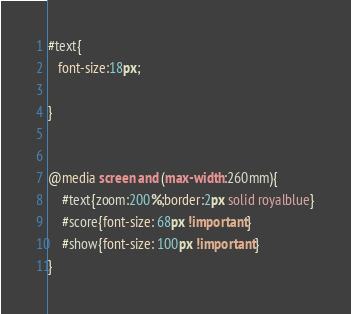<code> <loc_0><loc_0><loc_500><loc_500><_CSS_>#text{
   font-size:18px;

}


@media screen and (max-width:260mm){
    #text{zoom:200%;border:2px solid royalblue}
    #score{font-size: 68px !important}
    #show{font-size: 100px !important}
}</code> 